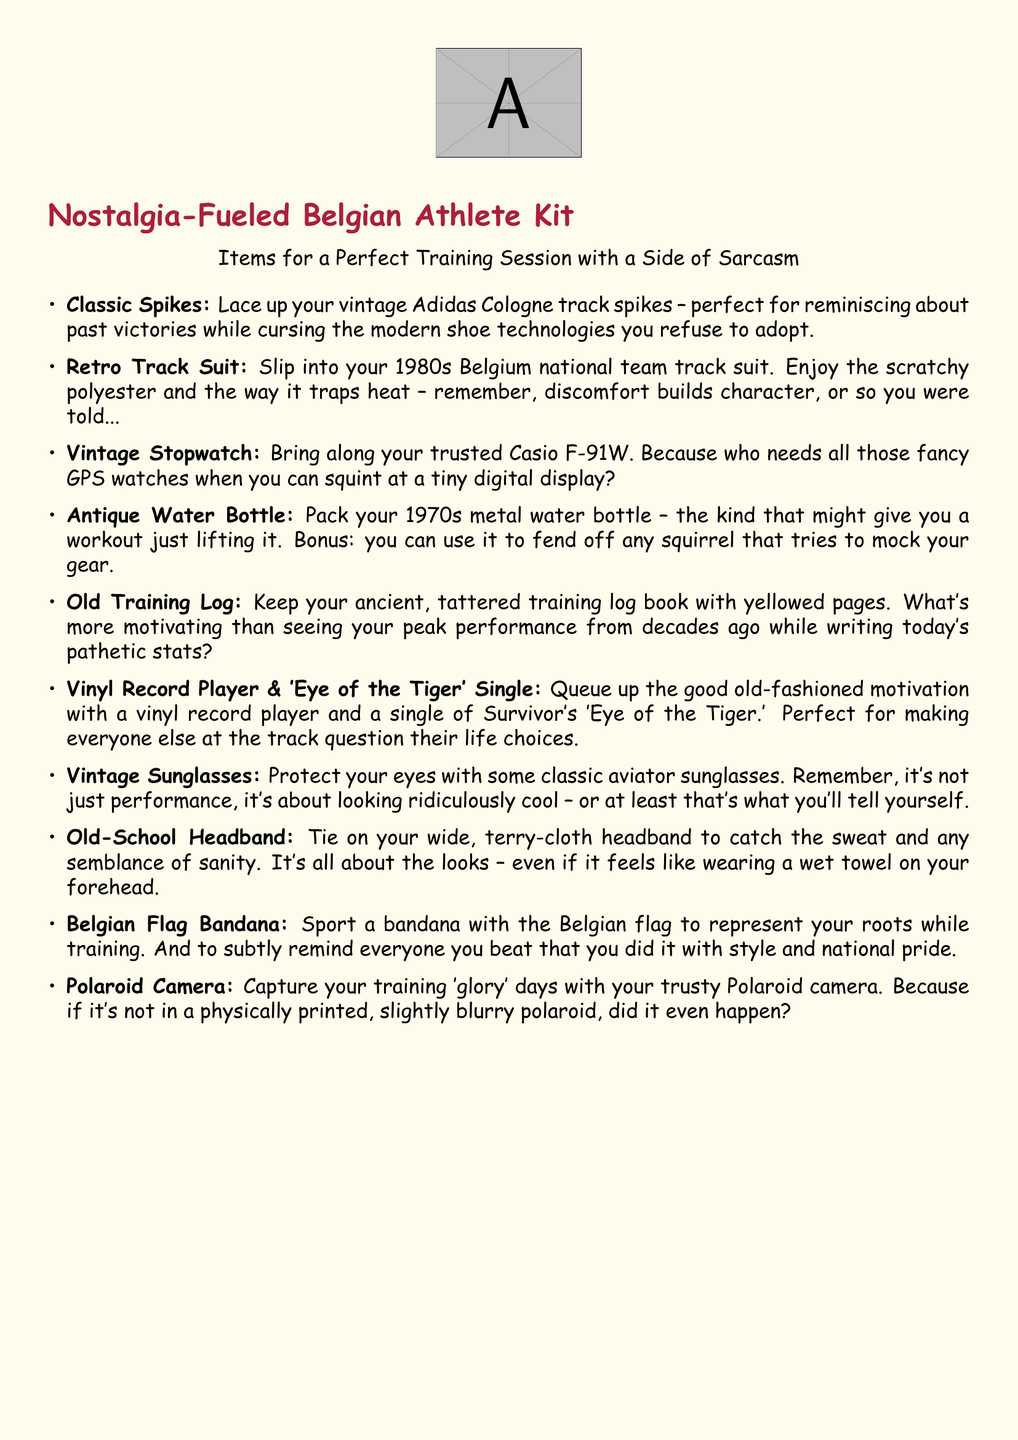What item is suggested for protecting the eyes? The document mentions vintage aviator sunglasses as a protective item for the eyes.
Answer: Vintage Sunglasses What decade is the retro track suit from? The text states that the retro track suit is from the 1980s, specifically mentioning the Belgium national team.
Answer: 1980s What brand of stopwatch is recommended? The recommendation in the document is for the Casio F-91W stopwatch for its simplicity compared to modern devices.
Answer: Casio F-91W Which motivational vinyl single is included in the kit? The packing list includes the vinyl single of 'Eye of the Tiger' by Survivor as a source of motivation.
Answer: 'Eye of the Tiger' What type of water bottle is mentioned? The document describes an antique metal water bottle from the 1970s that can provide a workout just by lifting it.
Answer: 1970s metal water bottle How does the packing list suggest capturing training moments? It suggests using a trusty Polaroid camera to capture training moments, emphasizing physical prints over digital.
Answer: Polaroid camera What is the purpose of the Belgian flag bandana? The bandana serves to represent the athlete's roots and to show national pride while training, as stated in the document.
Answer: Represent roots Which item is noted for potentially causing self-reflection among others at the track? The vinyl record player, coupled with the motivational single, is noted to cause self-reflection among others.
Answer: Vinyl record player What does the old-school headband do? According to the document, the headband is meant to catch sweat and maintain appearances while training.
Answer: Catch sweat 